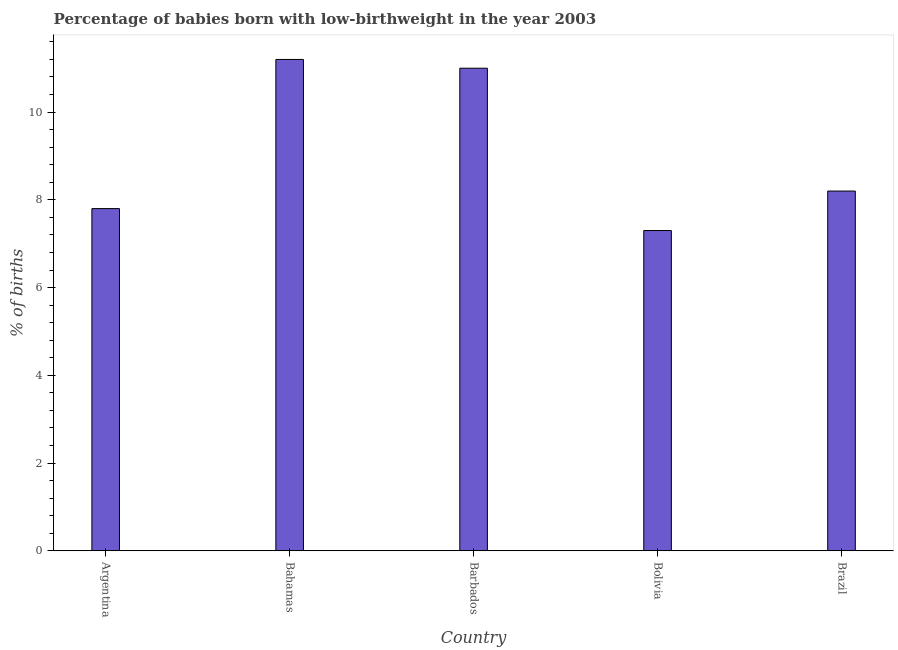Does the graph contain grids?
Keep it short and to the point. No. What is the title of the graph?
Your response must be concise. Percentage of babies born with low-birthweight in the year 2003. What is the label or title of the X-axis?
Your answer should be compact. Country. What is the label or title of the Y-axis?
Make the answer very short. % of births. Across all countries, what is the maximum percentage of babies who were born with low-birthweight?
Ensure brevity in your answer.  11.2. Across all countries, what is the minimum percentage of babies who were born with low-birthweight?
Your answer should be very brief. 7.3. In which country was the percentage of babies who were born with low-birthweight maximum?
Your answer should be very brief. Bahamas. In which country was the percentage of babies who were born with low-birthweight minimum?
Provide a succinct answer. Bolivia. What is the sum of the percentage of babies who were born with low-birthweight?
Make the answer very short. 45.5. What is the average percentage of babies who were born with low-birthweight per country?
Ensure brevity in your answer.  9.1. What is the median percentage of babies who were born with low-birthweight?
Your answer should be compact. 8.2. In how many countries, is the percentage of babies who were born with low-birthweight greater than 8 %?
Make the answer very short. 3. What is the ratio of the percentage of babies who were born with low-birthweight in Argentina to that in Bahamas?
Give a very brief answer. 0.7. Is the percentage of babies who were born with low-birthweight in Argentina less than that in Bahamas?
Offer a terse response. Yes. Is the difference between the percentage of babies who were born with low-birthweight in Barbados and Brazil greater than the difference between any two countries?
Provide a short and direct response. No. What is the difference between the highest and the lowest percentage of babies who were born with low-birthweight?
Your answer should be very brief. 3.9. What is the % of births in Bahamas?
Make the answer very short. 11.2. What is the % of births of Bolivia?
Keep it short and to the point. 7.3. What is the % of births of Brazil?
Give a very brief answer. 8.2. What is the difference between the % of births in Argentina and Barbados?
Provide a short and direct response. -3.2. What is the difference between the % of births in Argentina and Bolivia?
Offer a very short reply. 0.5. What is the difference between the % of births in Bahamas and Bolivia?
Your answer should be very brief. 3.9. What is the difference between the % of births in Bahamas and Brazil?
Provide a succinct answer. 3. What is the difference between the % of births in Barbados and Bolivia?
Offer a very short reply. 3.7. What is the difference between the % of births in Barbados and Brazil?
Ensure brevity in your answer.  2.8. What is the difference between the % of births in Bolivia and Brazil?
Ensure brevity in your answer.  -0.9. What is the ratio of the % of births in Argentina to that in Bahamas?
Offer a very short reply. 0.7. What is the ratio of the % of births in Argentina to that in Barbados?
Offer a terse response. 0.71. What is the ratio of the % of births in Argentina to that in Bolivia?
Your answer should be compact. 1.07. What is the ratio of the % of births in Argentina to that in Brazil?
Provide a short and direct response. 0.95. What is the ratio of the % of births in Bahamas to that in Barbados?
Keep it short and to the point. 1.02. What is the ratio of the % of births in Bahamas to that in Bolivia?
Provide a succinct answer. 1.53. What is the ratio of the % of births in Bahamas to that in Brazil?
Ensure brevity in your answer.  1.37. What is the ratio of the % of births in Barbados to that in Bolivia?
Provide a succinct answer. 1.51. What is the ratio of the % of births in Barbados to that in Brazil?
Provide a succinct answer. 1.34. What is the ratio of the % of births in Bolivia to that in Brazil?
Provide a short and direct response. 0.89. 